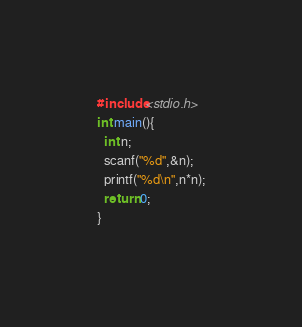<code> <loc_0><loc_0><loc_500><loc_500><_C_>#include<stdio.h>
int main(){
  int n;
  scanf("%d",&n);
  printf("%d\n",n*n);
  return 0;
}
</code> 